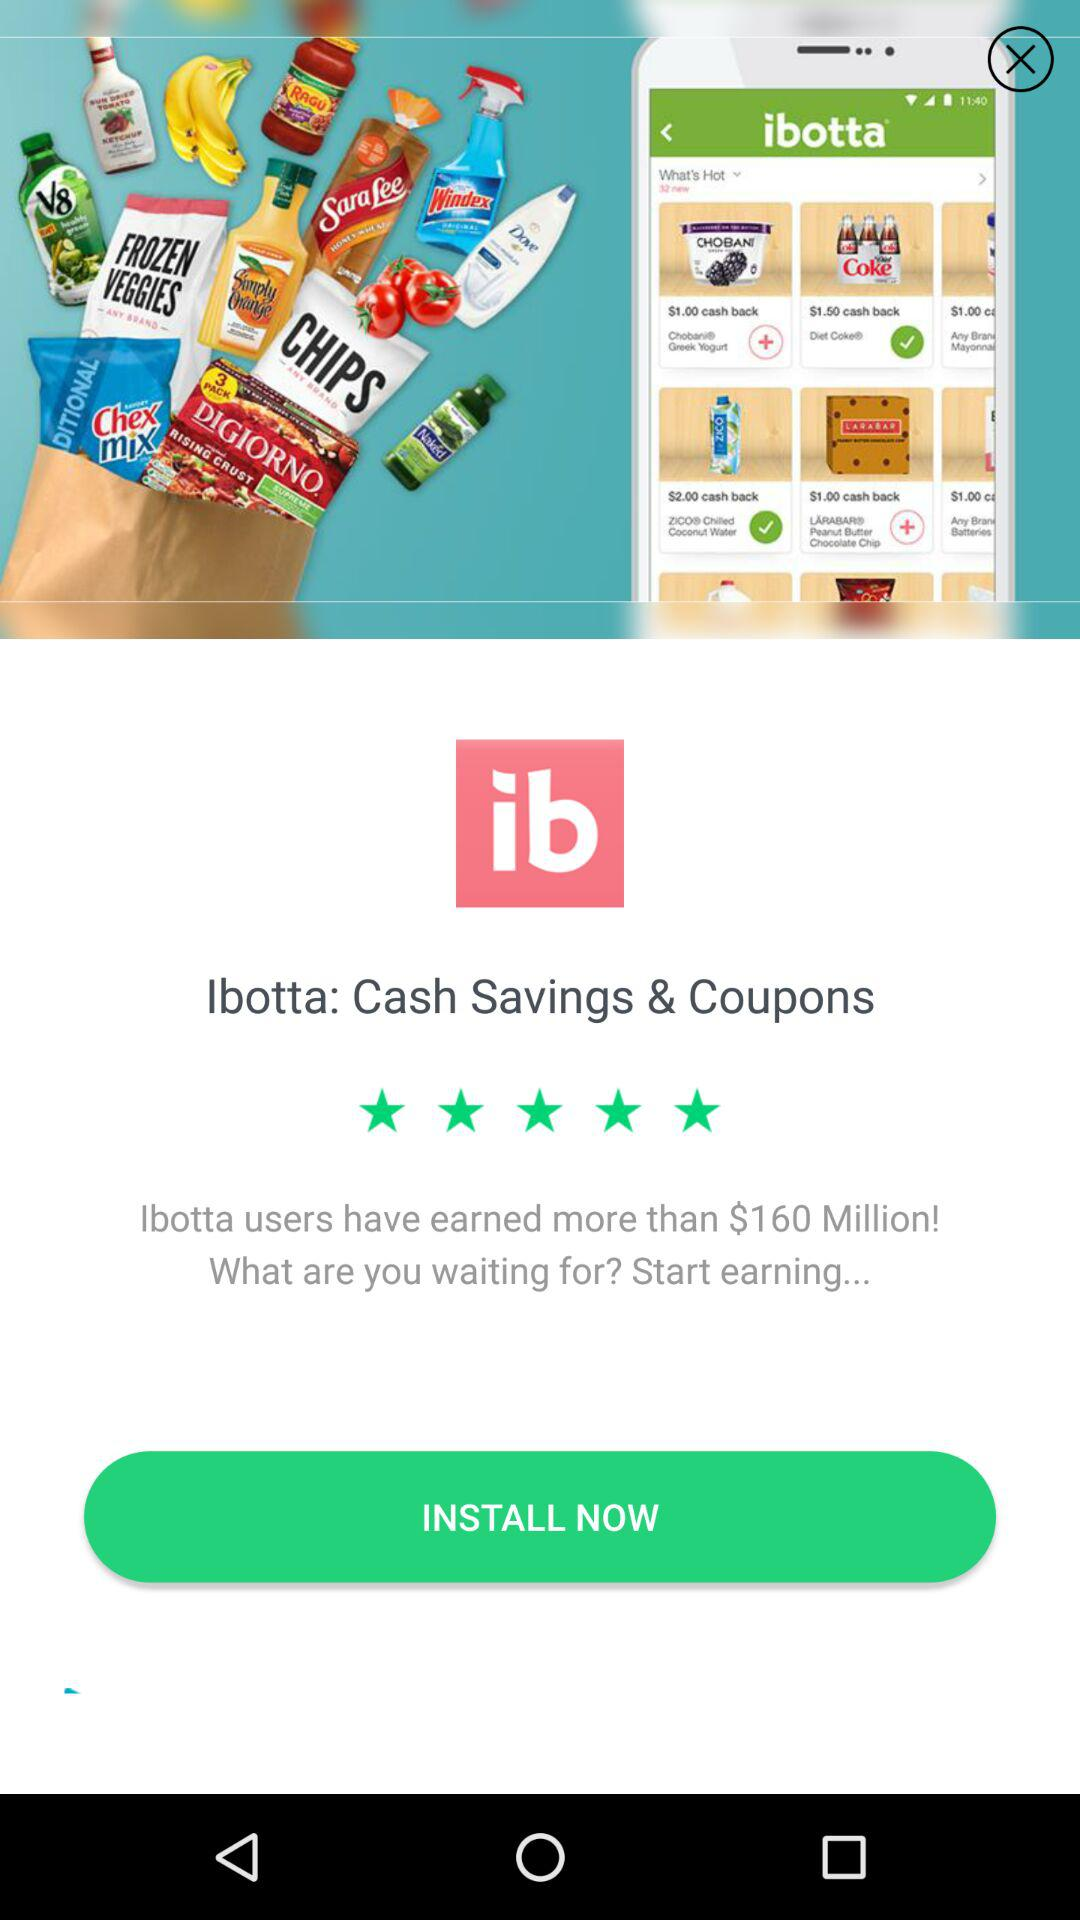What is the application name? The application name is "Ibotta: Cash Savings & Coupons". 